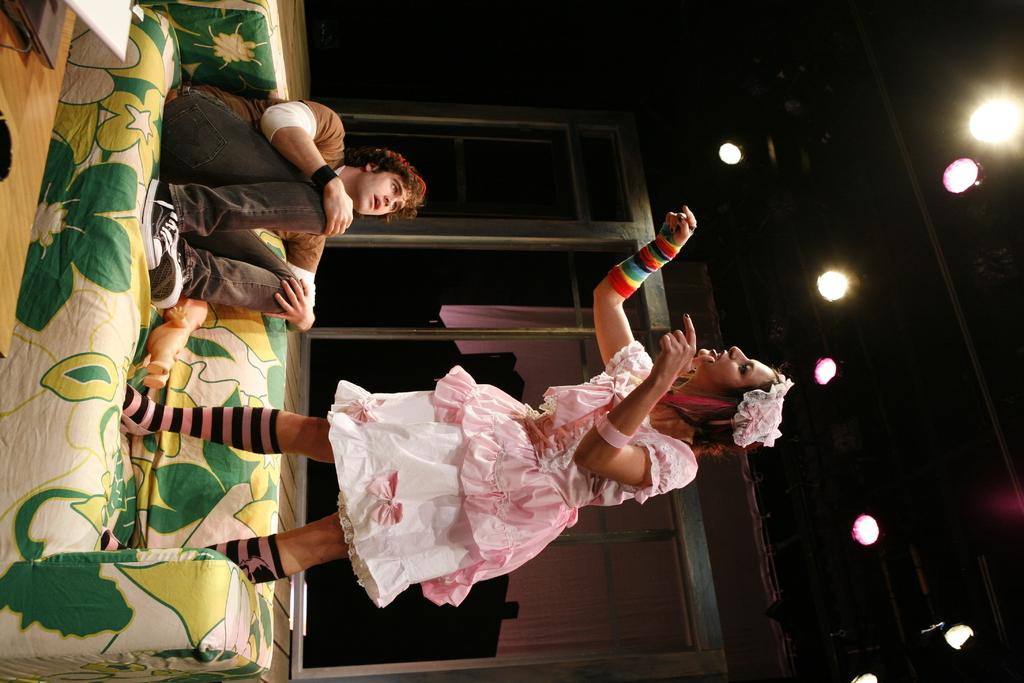How many people are in the image? There is a woman and a man in the image. What are the positions of the woman and the man in the image? The woman is standing, and the man is sitting. What piece of furniture is present in the image? There is a couch in the image. What type of surface is visible in the image? There is a wooden surface in the image. What electronic device can be seen in the image? There is a laptop in the image. What type of illumination is present in the image? There are lights in the image. What type of dinner is being served on the wooden surface in the image? There is no dinner present in the image; only a laptop and lights are visible on the wooden surface. How does the man show respect to the woman in the image? The image does not depict any actions or interactions that would indicate respect between the man and the woman. 